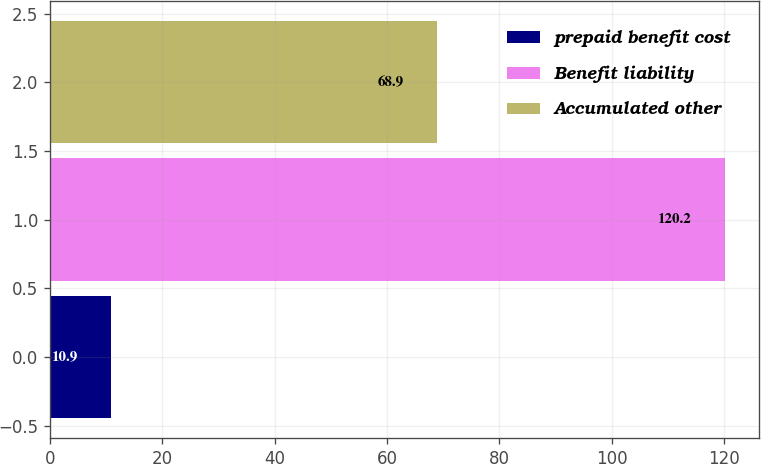<chart> <loc_0><loc_0><loc_500><loc_500><bar_chart><fcel>prepaid benefit cost<fcel>Benefit liability<fcel>Accumulated other<nl><fcel>10.9<fcel>120.2<fcel>68.9<nl></chart> 